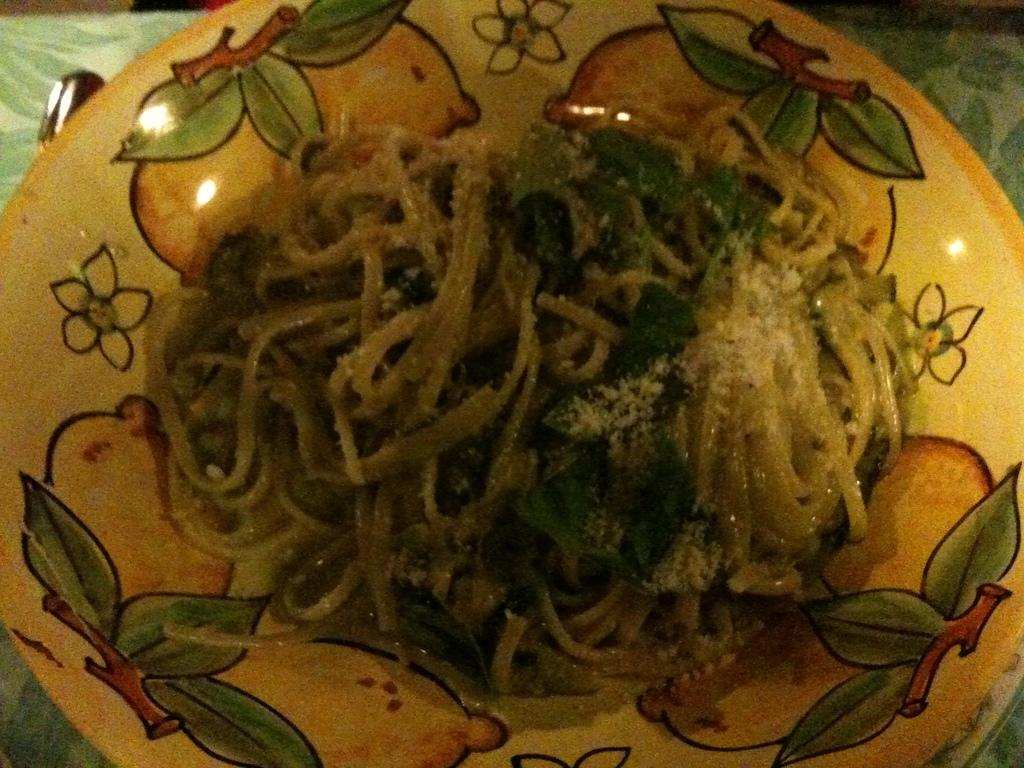What is the main piece of furniture in the image? There is a table in the image. What is placed on the table? The table has a plate on it. What is on the plate? There is food in the plate. How many balls are visible on the table in the image? There are no balls present in the image. What type of toad can be seen sitting on the plate in the image? There is no toad present in the image; it features a plate with food on it. 